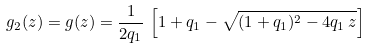Convert formula to latex. <formula><loc_0><loc_0><loc_500><loc_500>g _ { 2 } ( z ) = g ( z ) = \frac { 1 } { 2 q _ { 1 } } \, \left [ 1 + q _ { 1 } - \sqrt { ( 1 + q _ { 1 } ) ^ { 2 } - 4 q _ { 1 } \, z } \right ]</formula> 